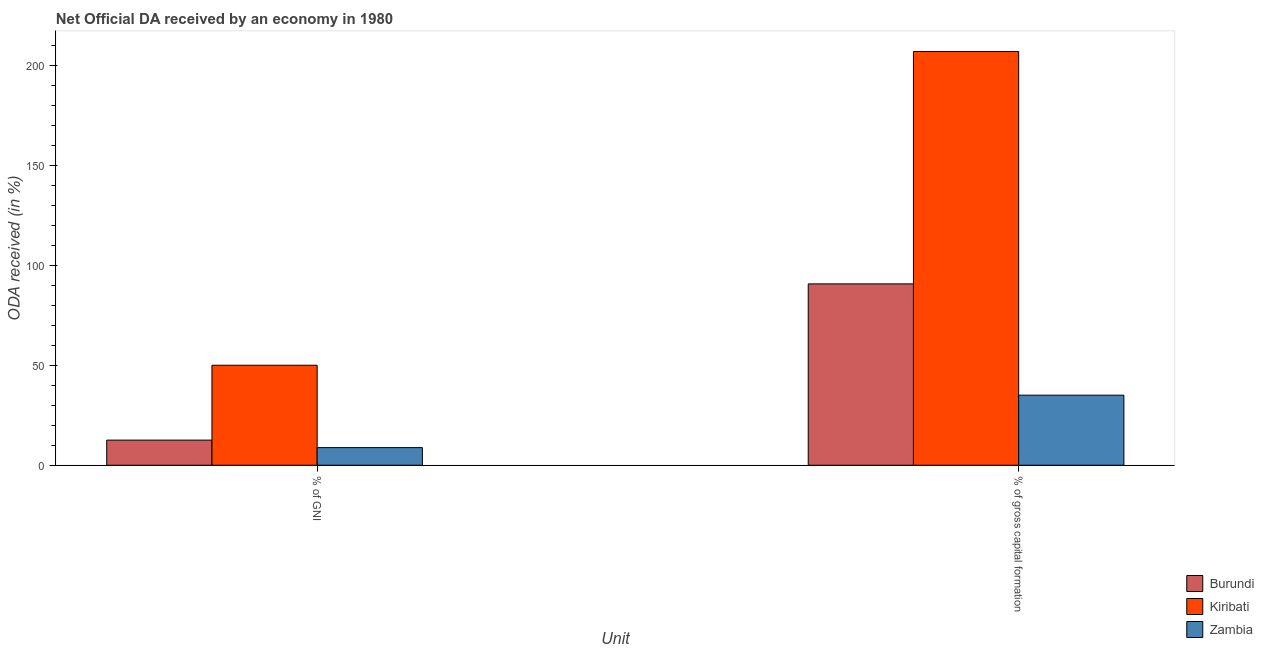How many different coloured bars are there?
Provide a short and direct response. 3. Are the number of bars per tick equal to the number of legend labels?
Keep it short and to the point. Yes. Are the number of bars on each tick of the X-axis equal?
Your response must be concise. Yes. What is the label of the 1st group of bars from the left?
Offer a terse response. % of GNI. What is the oda received as percentage of gross capital formation in Zambia?
Your answer should be very brief. 35.07. Across all countries, what is the maximum oda received as percentage of gni?
Your answer should be compact. 50.06. Across all countries, what is the minimum oda received as percentage of gross capital formation?
Provide a succinct answer. 35.07. In which country was the oda received as percentage of gross capital formation maximum?
Ensure brevity in your answer.  Kiribati. In which country was the oda received as percentage of gross capital formation minimum?
Keep it short and to the point. Zambia. What is the total oda received as percentage of gni in the graph?
Ensure brevity in your answer.  71.46. What is the difference between the oda received as percentage of gross capital formation in Zambia and that in Burundi?
Your answer should be compact. -55.72. What is the difference between the oda received as percentage of gross capital formation in Zambia and the oda received as percentage of gni in Burundi?
Provide a succinct answer. 22.49. What is the average oda received as percentage of gni per country?
Keep it short and to the point. 23.82. What is the difference between the oda received as percentage of gni and oda received as percentage of gross capital formation in Zambia?
Offer a very short reply. -26.25. In how many countries, is the oda received as percentage of gross capital formation greater than 20 %?
Offer a very short reply. 3. What is the ratio of the oda received as percentage of gross capital formation in Zambia to that in Kiribati?
Provide a succinct answer. 0.17. Is the oda received as percentage of gni in Burundi less than that in Kiribati?
Offer a terse response. Yes. What does the 2nd bar from the left in % of GNI represents?
Give a very brief answer. Kiribati. What does the 3rd bar from the right in % of gross capital formation represents?
Provide a short and direct response. Burundi. Are all the bars in the graph horizontal?
Offer a very short reply. No. Are the values on the major ticks of Y-axis written in scientific E-notation?
Offer a terse response. No. Does the graph contain any zero values?
Provide a succinct answer. No. Does the graph contain grids?
Make the answer very short. No. Where does the legend appear in the graph?
Provide a short and direct response. Bottom right. What is the title of the graph?
Keep it short and to the point. Net Official DA received by an economy in 1980. Does "Cote d'Ivoire" appear as one of the legend labels in the graph?
Your response must be concise. No. What is the label or title of the X-axis?
Provide a succinct answer. Unit. What is the label or title of the Y-axis?
Give a very brief answer. ODA received (in %). What is the ODA received (in %) in Burundi in % of GNI?
Ensure brevity in your answer.  12.58. What is the ODA received (in %) of Kiribati in % of GNI?
Provide a short and direct response. 50.06. What is the ODA received (in %) of Zambia in % of GNI?
Your response must be concise. 8.82. What is the ODA received (in %) in Burundi in % of gross capital formation?
Your answer should be very brief. 90.79. What is the ODA received (in %) of Kiribati in % of gross capital formation?
Offer a very short reply. 207.12. What is the ODA received (in %) of Zambia in % of gross capital formation?
Your answer should be compact. 35.07. Across all Unit, what is the maximum ODA received (in %) of Burundi?
Provide a short and direct response. 90.79. Across all Unit, what is the maximum ODA received (in %) in Kiribati?
Ensure brevity in your answer.  207.12. Across all Unit, what is the maximum ODA received (in %) of Zambia?
Your response must be concise. 35.07. Across all Unit, what is the minimum ODA received (in %) of Burundi?
Offer a very short reply. 12.58. Across all Unit, what is the minimum ODA received (in %) in Kiribati?
Make the answer very short. 50.06. Across all Unit, what is the minimum ODA received (in %) of Zambia?
Make the answer very short. 8.82. What is the total ODA received (in %) in Burundi in the graph?
Offer a very short reply. 103.37. What is the total ODA received (in %) of Kiribati in the graph?
Provide a succinct answer. 257.18. What is the total ODA received (in %) of Zambia in the graph?
Provide a succinct answer. 43.9. What is the difference between the ODA received (in %) in Burundi in % of GNI and that in % of gross capital formation?
Keep it short and to the point. -78.21. What is the difference between the ODA received (in %) in Kiribati in % of GNI and that in % of gross capital formation?
Your answer should be compact. -157.06. What is the difference between the ODA received (in %) of Zambia in % of GNI and that in % of gross capital formation?
Give a very brief answer. -26.25. What is the difference between the ODA received (in %) of Burundi in % of GNI and the ODA received (in %) of Kiribati in % of gross capital formation?
Your answer should be very brief. -194.54. What is the difference between the ODA received (in %) of Burundi in % of GNI and the ODA received (in %) of Zambia in % of gross capital formation?
Your answer should be compact. -22.49. What is the difference between the ODA received (in %) in Kiribati in % of GNI and the ODA received (in %) in Zambia in % of gross capital formation?
Make the answer very short. 14.99. What is the average ODA received (in %) in Burundi per Unit?
Provide a succinct answer. 51.68. What is the average ODA received (in %) of Kiribati per Unit?
Your answer should be very brief. 128.59. What is the average ODA received (in %) of Zambia per Unit?
Your answer should be compact. 21.95. What is the difference between the ODA received (in %) in Burundi and ODA received (in %) in Kiribati in % of GNI?
Provide a succinct answer. -37.48. What is the difference between the ODA received (in %) of Burundi and ODA received (in %) of Zambia in % of GNI?
Keep it short and to the point. 3.75. What is the difference between the ODA received (in %) in Kiribati and ODA received (in %) in Zambia in % of GNI?
Ensure brevity in your answer.  41.23. What is the difference between the ODA received (in %) in Burundi and ODA received (in %) in Kiribati in % of gross capital formation?
Your answer should be very brief. -116.33. What is the difference between the ODA received (in %) of Burundi and ODA received (in %) of Zambia in % of gross capital formation?
Offer a very short reply. 55.72. What is the difference between the ODA received (in %) of Kiribati and ODA received (in %) of Zambia in % of gross capital formation?
Ensure brevity in your answer.  172.05. What is the ratio of the ODA received (in %) in Burundi in % of GNI to that in % of gross capital formation?
Offer a terse response. 0.14. What is the ratio of the ODA received (in %) of Kiribati in % of GNI to that in % of gross capital formation?
Provide a succinct answer. 0.24. What is the ratio of the ODA received (in %) in Zambia in % of GNI to that in % of gross capital formation?
Give a very brief answer. 0.25. What is the difference between the highest and the second highest ODA received (in %) of Burundi?
Your answer should be compact. 78.21. What is the difference between the highest and the second highest ODA received (in %) of Kiribati?
Provide a succinct answer. 157.06. What is the difference between the highest and the second highest ODA received (in %) of Zambia?
Provide a short and direct response. 26.25. What is the difference between the highest and the lowest ODA received (in %) in Burundi?
Give a very brief answer. 78.21. What is the difference between the highest and the lowest ODA received (in %) of Kiribati?
Your answer should be compact. 157.06. What is the difference between the highest and the lowest ODA received (in %) in Zambia?
Offer a terse response. 26.25. 